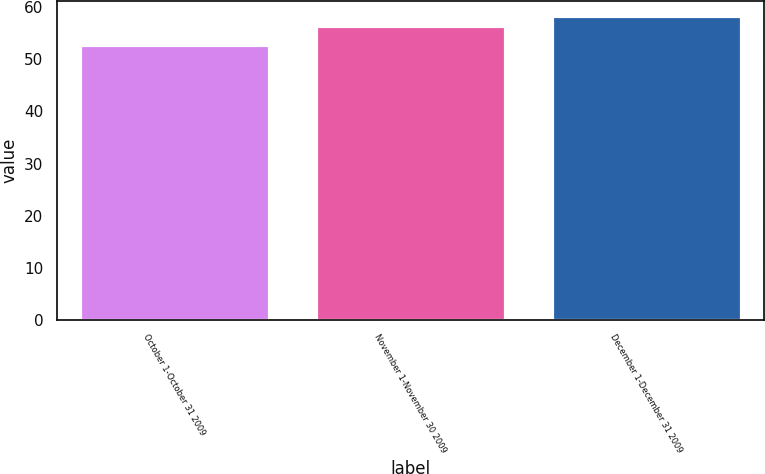<chart> <loc_0><loc_0><loc_500><loc_500><bar_chart><fcel>October 1-October 31 2009<fcel>November 1-November 30 2009<fcel>December 1-December 31 2009<nl><fcel>52.78<fcel>56.45<fcel>58.28<nl></chart> 